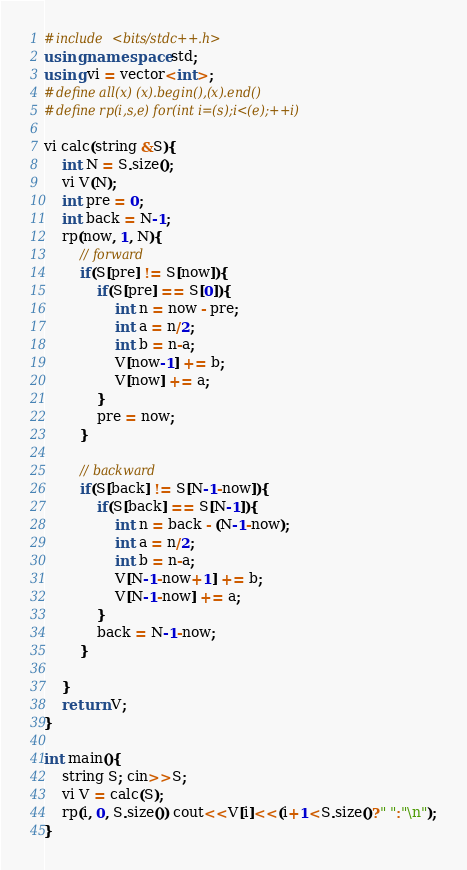Convert code to text. <code><loc_0><loc_0><loc_500><loc_500><_C++_>#include <bits/stdc++.h>
using namespace std;
using vi = vector<int>;
#define all(x) (x).begin(),(x).end()
#define rp(i,s,e) for(int i=(s);i<(e);++i)

vi calc(string &S){
	int N = S.size();
	vi V(N);
	int pre = 0;
	int back = N-1;
	rp(now, 1, N){
		// forward
		if(S[pre] != S[now]){
			if(S[pre] == S[0]){
				int n = now - pre;
				int a = n/2;
				int b = n-a;
				V[now-1] += b;
				V[now] += a;
			}
			pre = now;
		}

		// backward
		if(S[back] != S[N-1-now]){
			if(S[back] == S[N-1]){
				int n = back - (N-1-now);
				int a = n/2;
				int b = n-a;
				V[N-1-now+1] += b;
				V[N-1-now] += a;
			}
			back = N-1-now;
		}

	}
	return V;
}

int main(){
	string S; cin>>S;
	vi V = calc(S);
	rp(i, 0, S.size()) cout<<V[i]<<(i+1<S.size()?" ":"\n");
}
</code> 